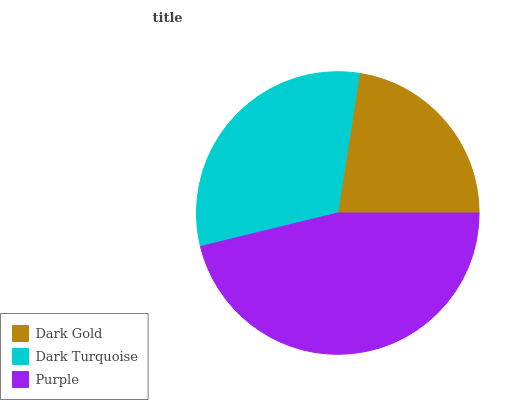Is Dark Gold the minimum?
Answer yes or no. Yes. Is Purple the maximum?
Answer yes or no. Yes. Is Dark Turquoise the minimum?
Answer yes or no. No. Is Dark Turquoise the maximum?
Answer yes or no. No. Is Dark Turquoise greater than Dark Gold?
Answer yes or no. Yes. Is Dark Gold less than Dark Turquoise?
Answer yes or no. Yes. Is Dark Gold greater than Dark Turquoise?
Answer yes or no. No. Is Dark Turquoise less than Dark Gold?
Answer yes or no. No. Is Dark Turquoise the high median?
Answer yes or no. Yes. Is Dark Turquoise the low median?
Answer yes or no. Yes. Is Dark Gold the high median?
Answer yes or no. No. Is Dark Gold the low median?
Answer yes or no. No. 